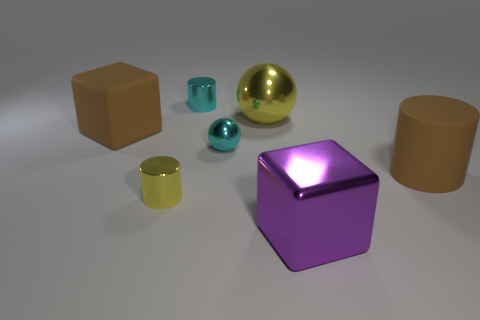What size is the rubber thing on the left side of the large yellow shiny sphere? The 'rubber thing' on the left side appears to be of moderate size in comparison to the surrounding objects. It's smaller than the large sphere but larger than the smallest objects in the scene. 